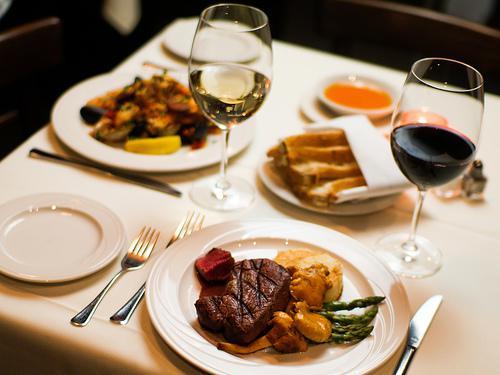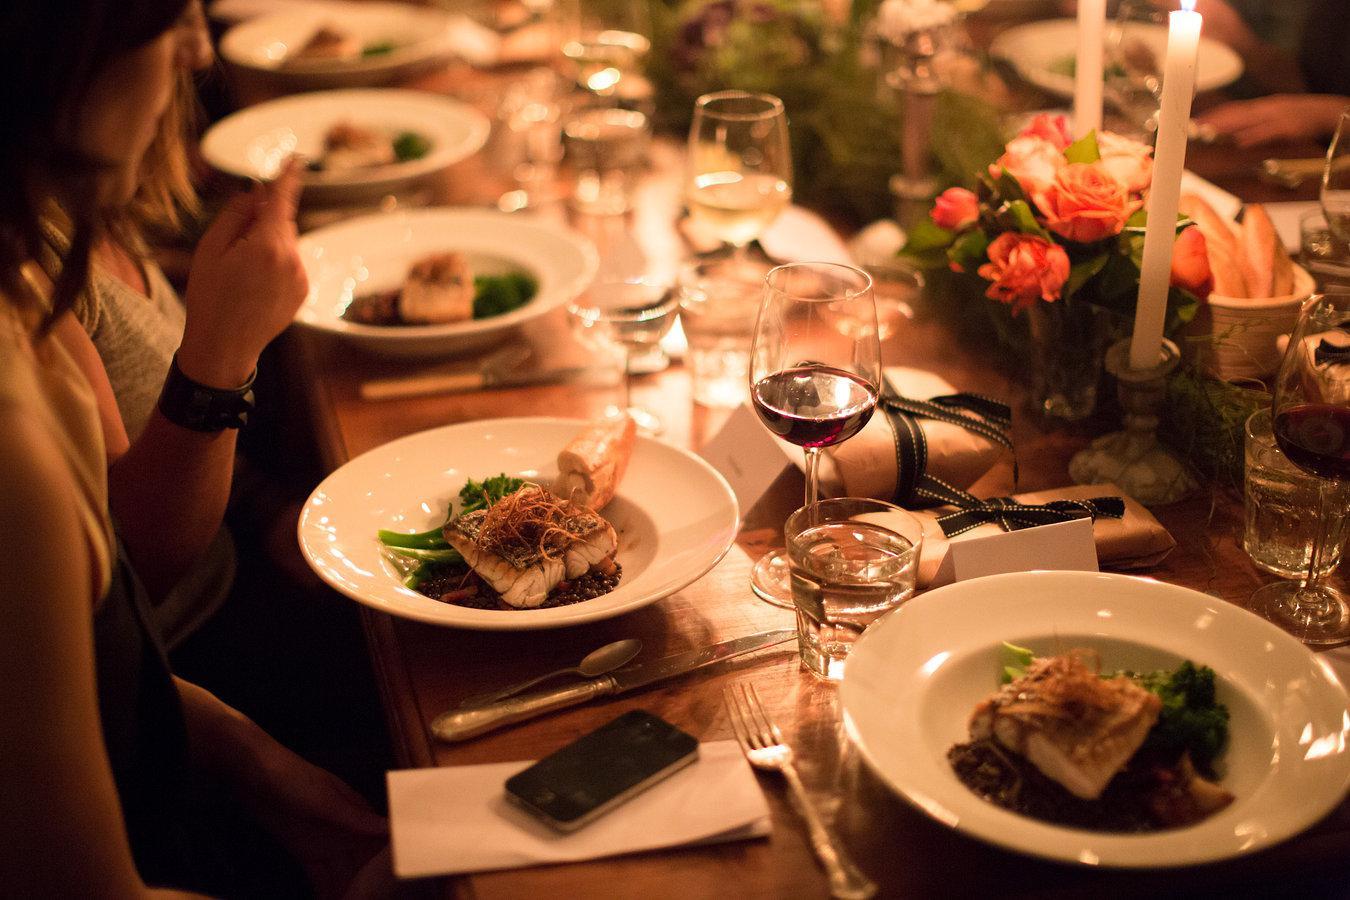The first image is the image on the left, the second image is the image on the right. For the images displayed, is the sentence "The table in the image on the left has a white table cloth." factually correct? Answer yes or no. Yes. The first image is the image on the left, the second image is the image on the right. Considering the images on both sides, is "Left image shows a table holding exactly two glasses, which contain dark wine." valid? Answer yes or no. No. 